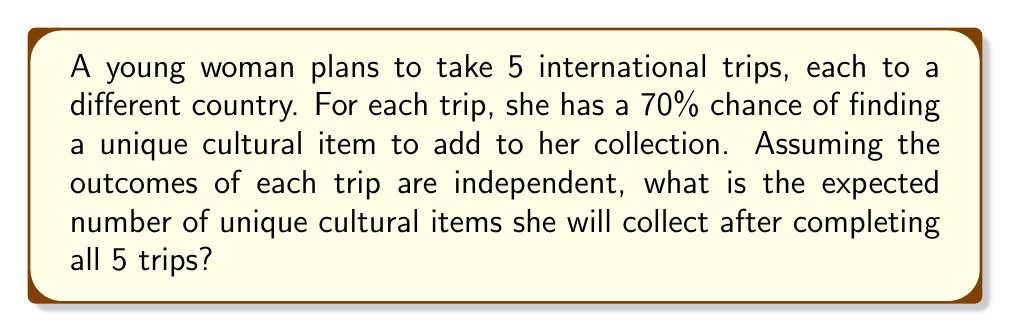Can you answer this question? Let's approach this step-by-step:

1) First, we need to understand what "expected value" means. It's the average outcome of an experiment if it is repeated many times.

2) In this case, each trip is a Bernoulli trial with probability $p = 0.7$ of success (finding a unique item).

3) The number of successes in $n$ independent Bernoulli trials follows a Binomial distribution.

4) The expected value of a Binomial distribution is given by the formula:

   $$E(X) = np$$

   where $n$ is the number of trials and $p$ is the probability of success on each trial.

5) In this problem:
   $n = 5$ (number of trips)
   $p = 0.7$ (probability of finding a unique item on each trip)

6) Plugging these values into the formula:

   $$E(X) = 5 * 0.7 = 3.5$$

Therefore, the expected number of unique cultural items collected after 5 trips is 3.5.
Answer: 3.5 items 